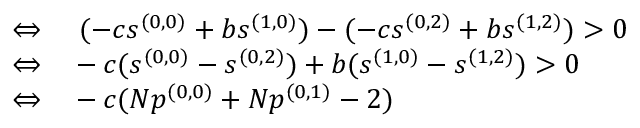Convert formula to latex. <formula><loc_0><loc_0><loc_500><loc_500>\begin{array} { r l } { \Leftrightarrow } & ( - c s ^ { ( 0 , 0 ) } + b s ^ { ( 1 , 0 ) } ) - ( - c s ^ { ( 0 , 2 ) } + b s ^ { ( 1 , 2 ) } ) > 0 } \\ { \Leftrightarrow } & - c ( s ^ { ( 0 , 0 ) } - s ^ { ( 0 , 2 ) } ) + b ( s ^ { ( 1 , 0 ) } - s ^ { ( 1 , 2 ) } ) > 0 } \\ { \Leftrightarrow } & - c ( N p ^ { ( 0 , 0 ) } + N p ^ { ( 0 , 1 ) } - 2 ) } \end{array}</formula> 